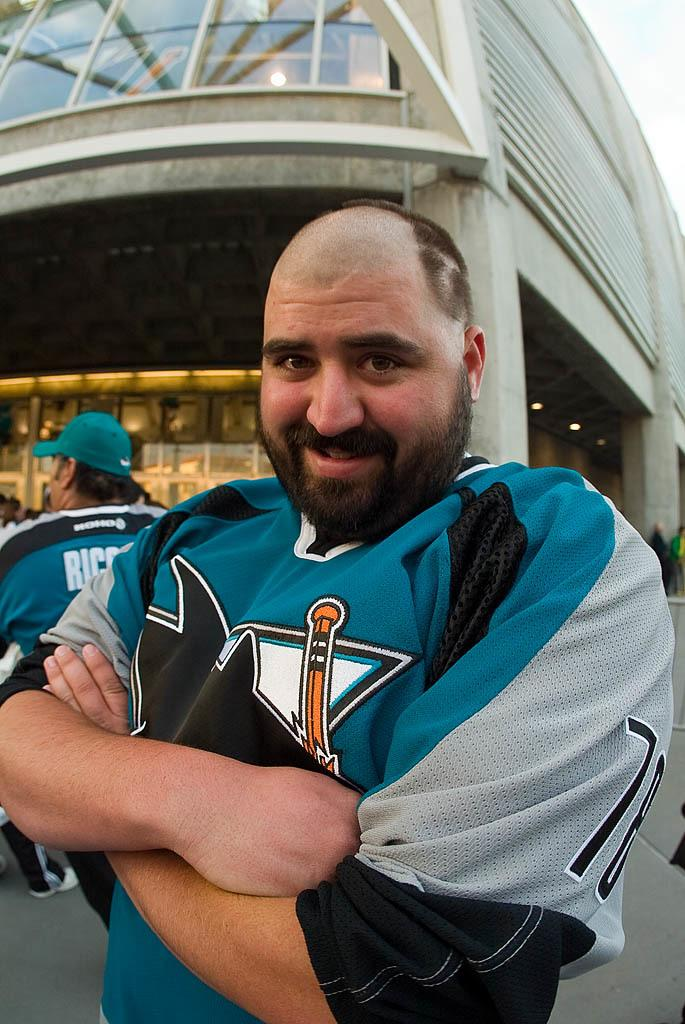Provide a one-sentence caption for the provided image. A sports fan wearing a umber 78 jersey has shaved the front part of his hair to make it look like a receding hairline. 